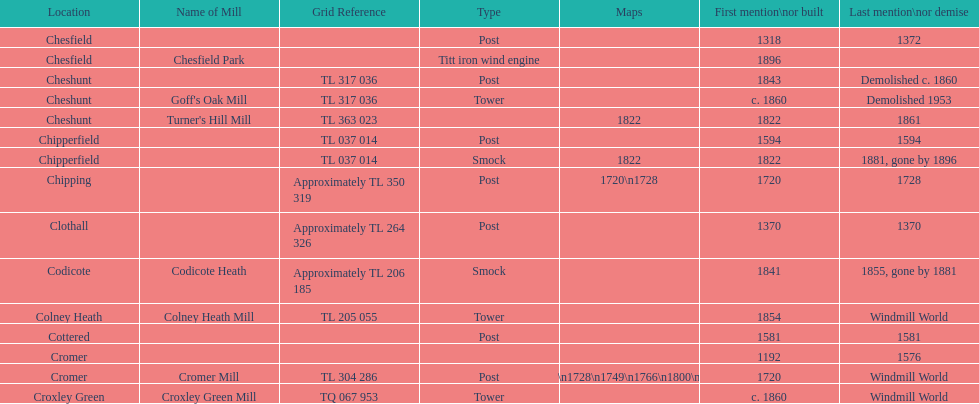Did cromer, chipperfield or cheshunt have the most windmills? Cheshunt. 